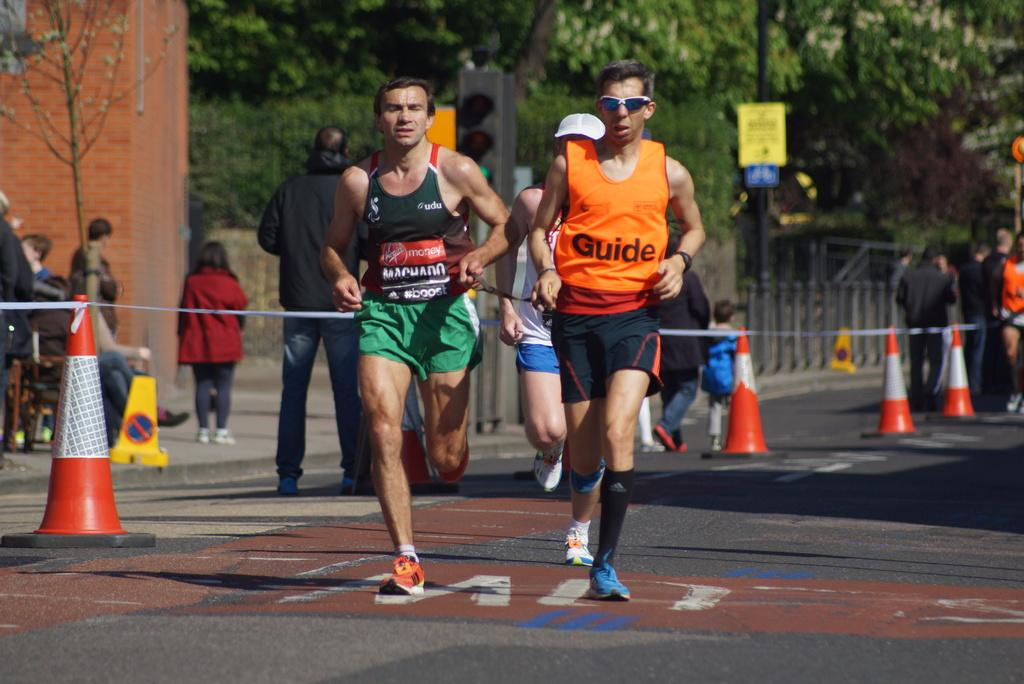<image>
Describe the image concisely. men running in a race wearing bibs from Virgin Money and #boost 